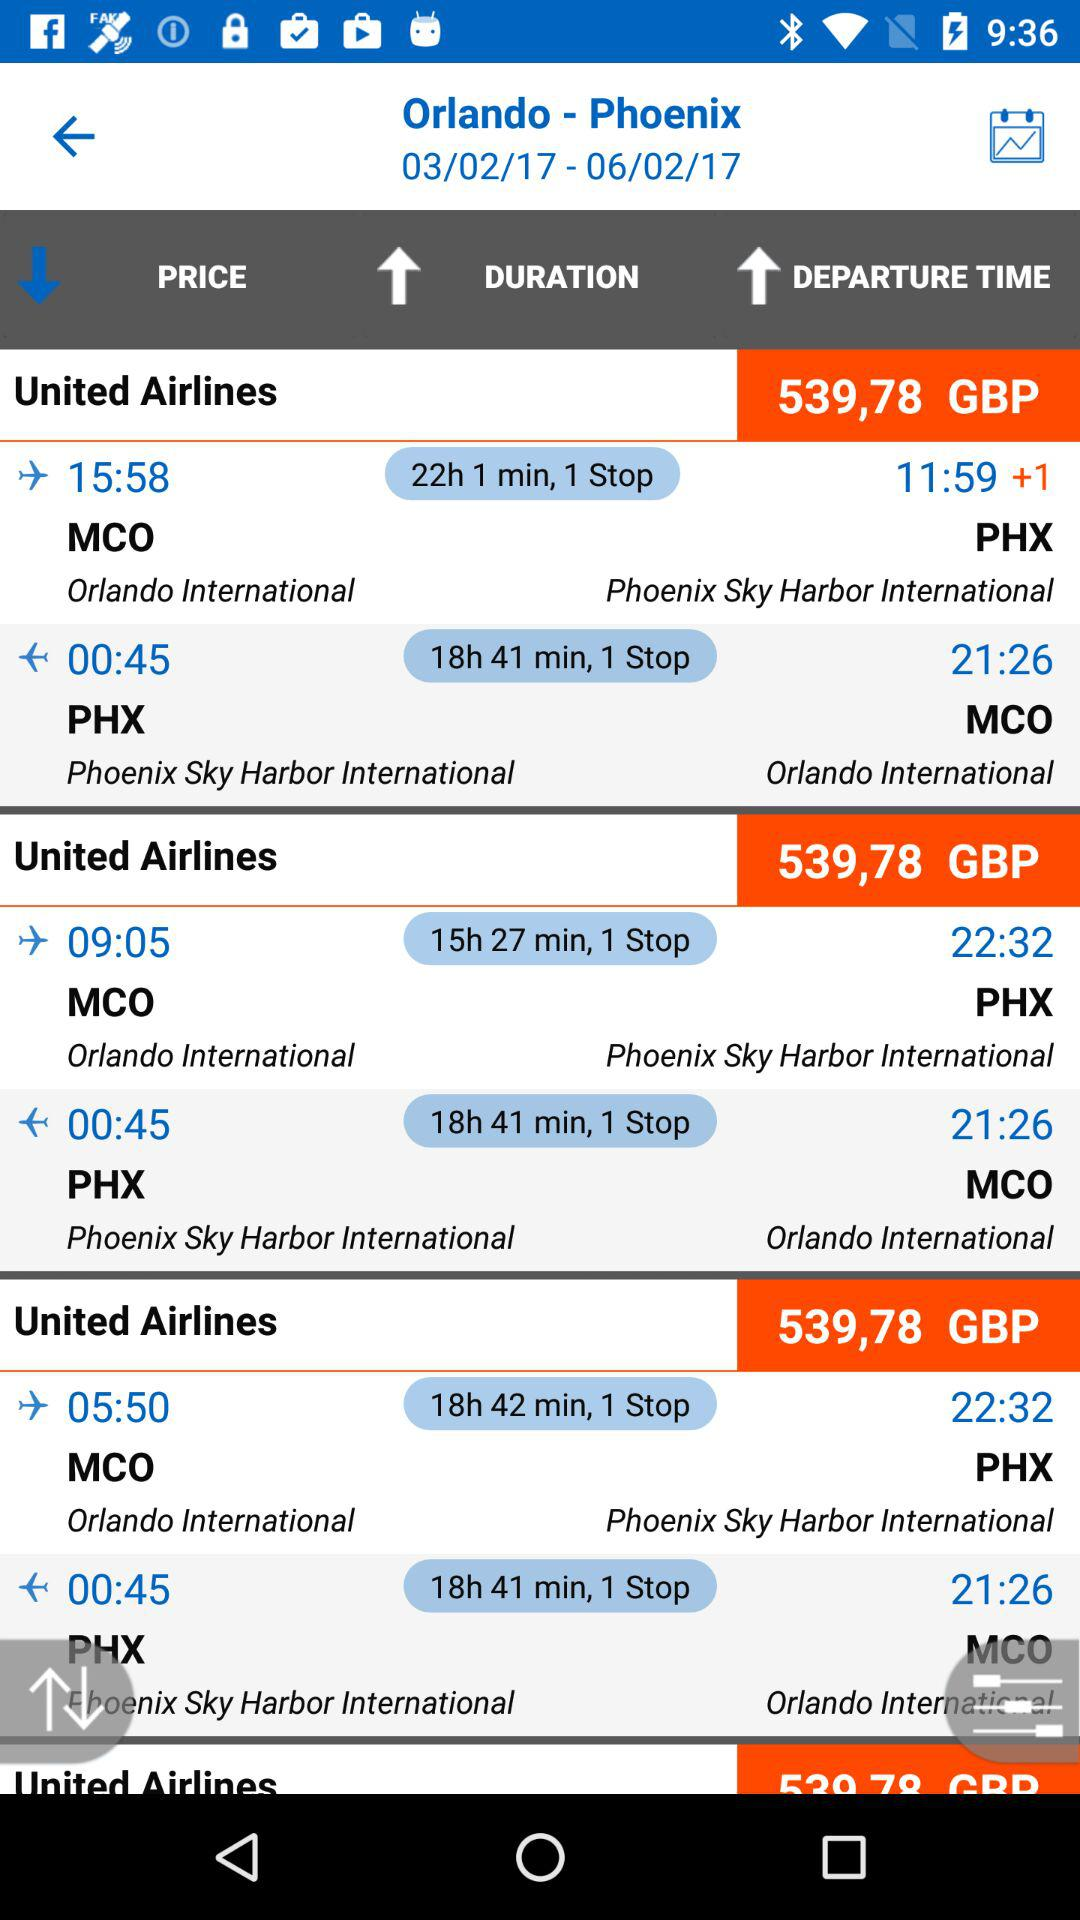How many flights are there?
Answer the question using a single word or phrase. 6 